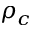<formula> <loc_0><loc_0><loc_500><loc_500>\rho _ { c }</formula> 